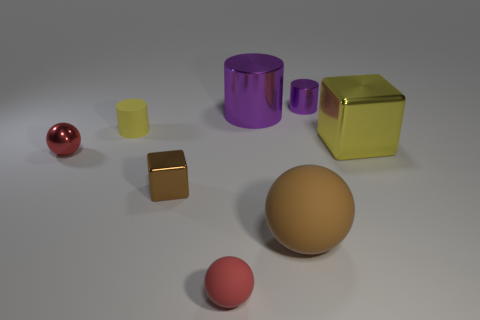Is there another red object that has the same shape as the small red metal object?
Offer a terse response. Yes. The big metallic object that is the same shape as the small yellow object is what color?
Ensure brevity in your answer.  Purple. Is there any other thing that has the same size as the red metal ball?
Offer a very short reply. Yes. What is the size of the yellow thing that is the same shape as the brown metallic object?
Provide a short and direct response. Large. Are there more rubber balls than small metal objects?
Your response must be concise. No. Is the yellow shiny thing the same shape as the big brown object?
Offer a terse response. No. What is the material of the large thing on the right side of the rubber thing that is to the right of the small rubber ball?
Provide a short and direct response. Metal. What is the material of the block that is the same color as the small rubber cylinder?
Provide a succinct answer. Metal. Is the size of the red metal ball the same as the yellow matte object?
Your answer should be compact. Yes. Are there any red balls that are left of the cylinder left of the brown shiny block?
Provide a short and direct response. Yes. 